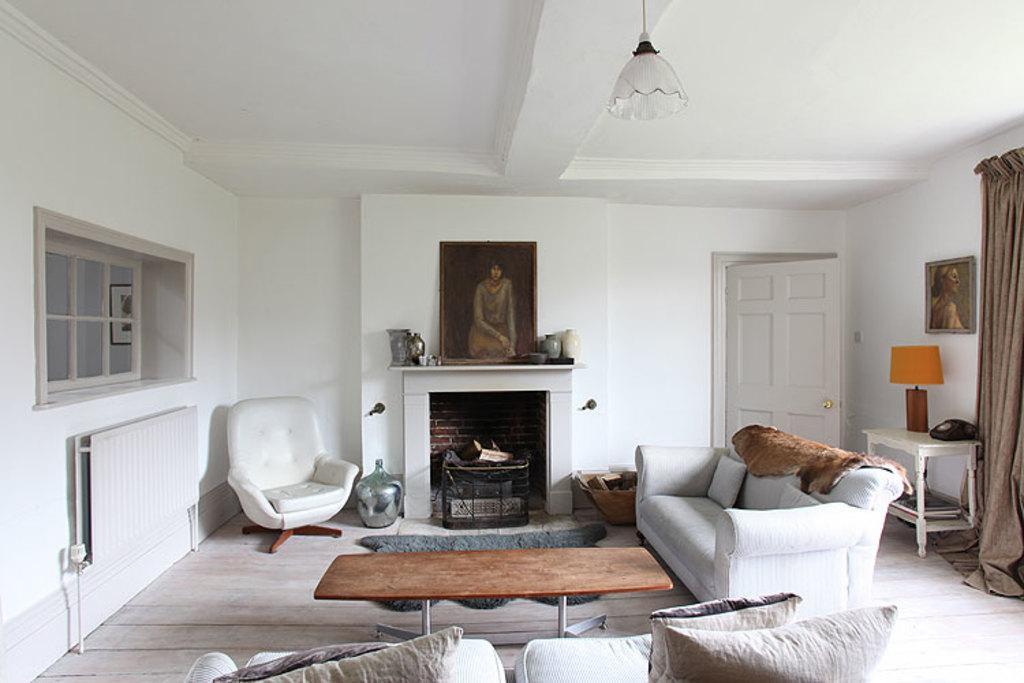Can you describe this image briefly? In this picture there are two sofas , brown table , room heater , glass windows ,lamp ,telephone ,photo frames , glass amenity. This scene is clicked inside a house. 